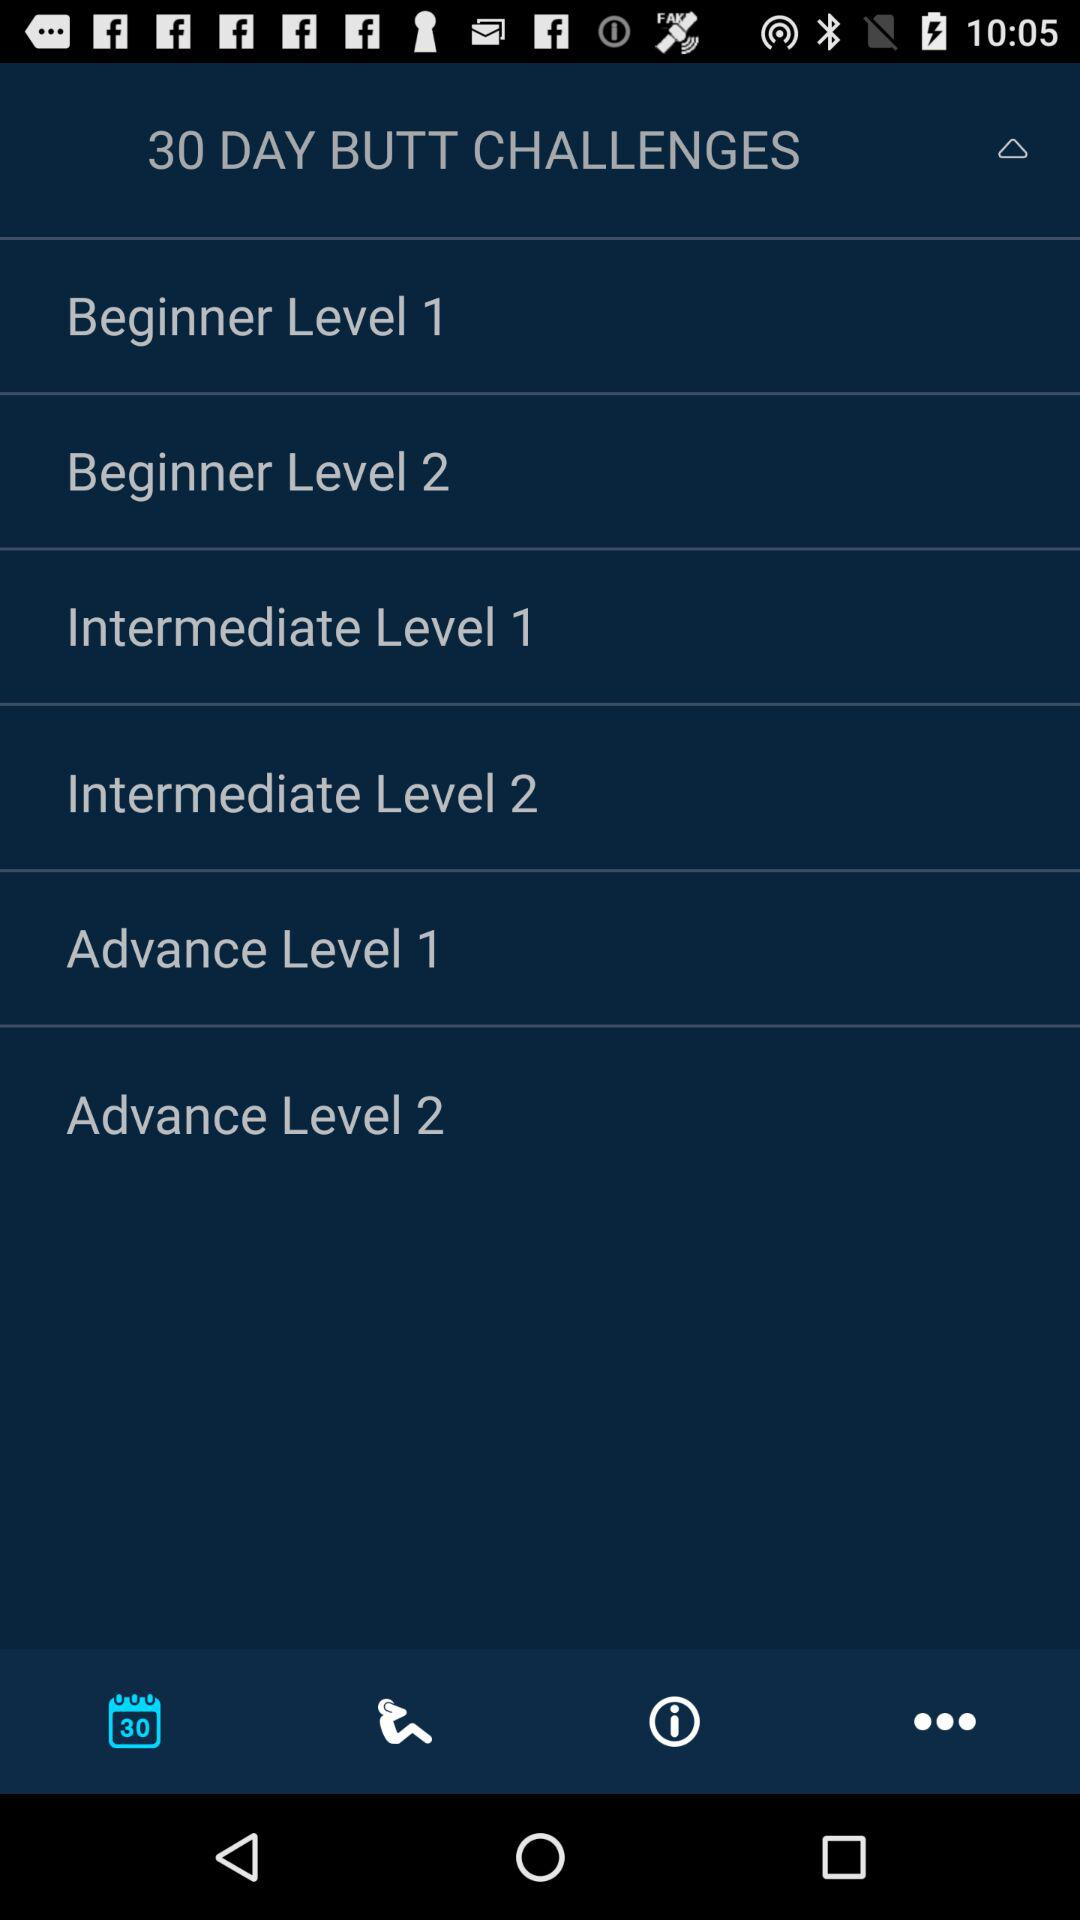How many beginner level challenges are there?
Answer the question using a single word or phrase. 2 